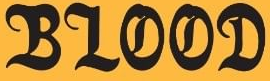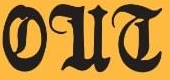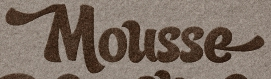What words can you see in these images in sequence, separated by a semicolon? BLOOD; OUT; Mousse 